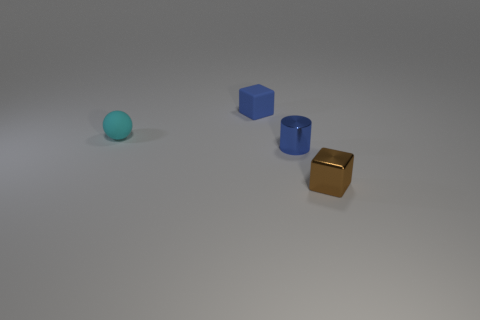Are there any other things that have the same shape as the small cyan rubber object?
Your answer should be compact. No. There is a block that is the same color as the tiny cylinder; what is it made of?
Make the answer very short. Rubber. There is a small thing to the left of the blue matte cube; what is its shape?
Provide a short and direct response. Sphere. What is the color of the other small thing that is made of the same material as the tiny brown object?
Provide a short and direct response. Blue. What material is the other thing that is the same shape as the tiny brown thing?
Make the answer very short. Rubber. The tiny cyan object is what shape?
Your answer should be very brief. Sphere. There is a thing that is behind the metal cube and in front of the matte sphere; what is its material?
Keep it short and to the point. Metal. There is a tiny blue object that is the same material as the sphere; what shape is it?
Give a very brief answer. Cube. There is a blue thing that is the same material as the brown block; what size is it?
Your response must be concise. Small. What is the shape of the thing that is both to the right of the cyan rubber object and on the left side of the tiny blue metallic thing?
Provide a succinct answer. Cube. 